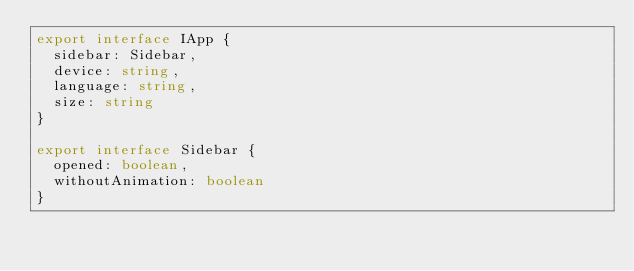<code> <loc_0><loc_0><loc_500><loc_500><_TypeScript_>export interface IApp {
  sidebar: Sidebar,
  device: string,
  language: string,
  size: string
}

export interface Sidebar {
  opened: boolean,
  withoutAnimation: boolean
}
</code> 